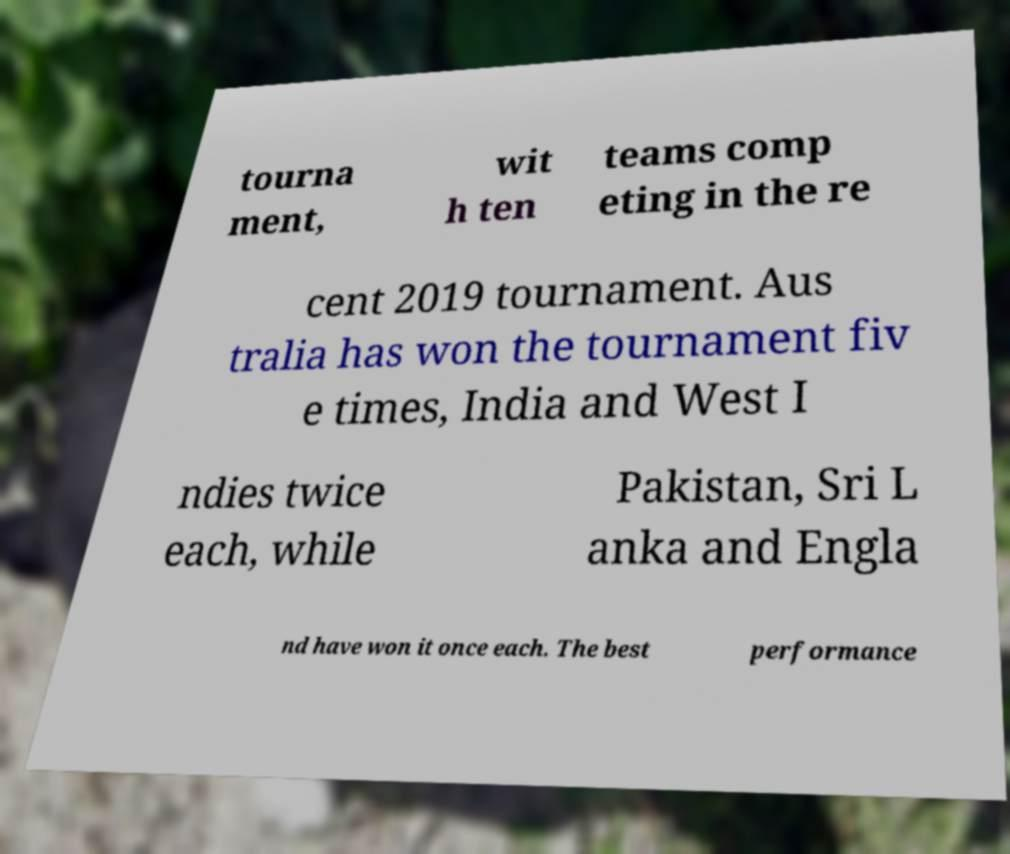Please identify and transcribe the text found in this image. tourna ment, wit h ten teams comp eting in the re cent 2019 tournament. Aus tralia has won the tournament fiv e times, India and West I ndies twice each, while Pakistan, Sri L anka and Engla nd have won it once each. The best performance 